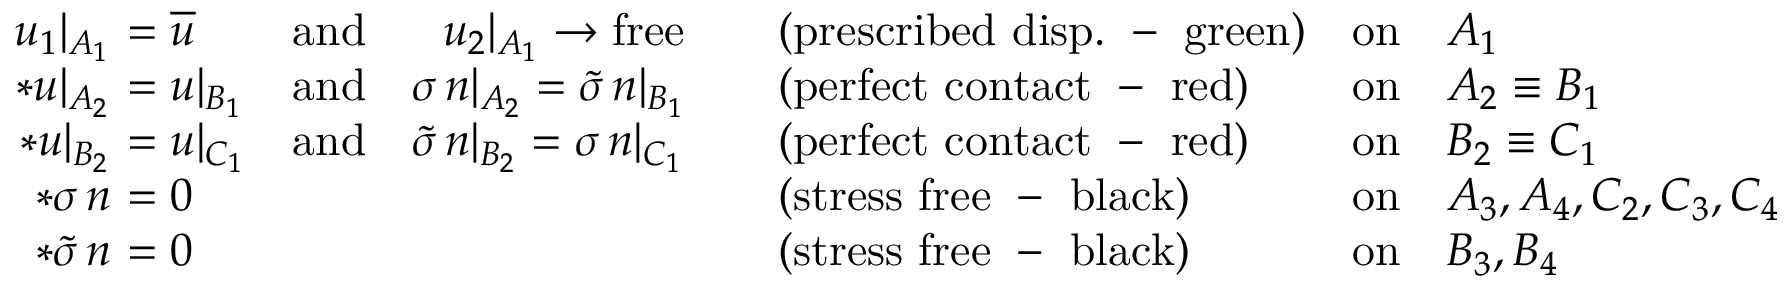Convert formula to latex. <formula><loc_0><loc_0><loc_500><loc_500>\begin{array} { r } { \begin{array} { r l l l l l } { u _ { 1 } | _ { A _ { 1 } } } & { \, = \overline { u } } & { a n d \quad \, u _ { 2 } | _ { A _ { 1 } } \to f r e e } & { \quad ( p r e s c r i b e d d i s p . - g r e e n ) } & { o n } & { A _ { 1 } } \\ { * u | _ { A _ { 2 } } } & { \, = u | _ { B _ { 1 } } } & { a n d \quad \sigma \, n | _ { A _ { 2 } } = \widetilde { \sigma } \, n | _ { B _ { 1 } } } & { \quad ( p e r f e c t c o n t a c t - r e d ) } & { o n } & { A _ { 2 } \equiv B _ { 1 } } \\ { * u | _ { B _ { 2 } } } & { \, = u | _ { C _ { 1 } } } & { a n d \quad \widetilde { \sigma } \, n | _ { B _ { 2 } } = \sigma \, n | _ { C _ { 1 } } } & { \quad ( p e r f e c t c o n t a c t - r e d ) } & { o n } & { B _ { 2 } \equiv C _ { 1 } } \\ { * \sigma \, n } & { \, = 0 } & & { \quad ( s t r e s s f r e e - b l a c k ) } & { o n } & { A _ { 3 } , A _ { 4 } , C _ { 2 } , C _ { 3 } , C _ { 4 } } \\ { * \widetilde { \sigma } \, n } & { \, = 0 } & & { \quad ( s t r e s s f r e e - b l a c k ) } & { o n } & { B _ { 3 } , B _ { 4 } } \end{array} } \end{array}</formula> 